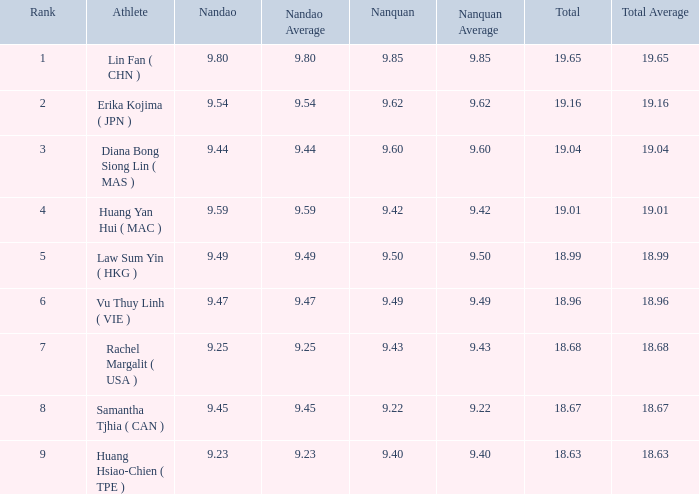Parse the full table. {'header': ['Rank', 'Athlete', 'Nandao', 'Nandao Average', 'Nanquan', 'Nanquan Average', 'Total', 'Total Average'], 'rows': [['1', 'Lin Fan ( CHN )', '9.80', '9.80', '9.85', '9.85', '19.65', '19.65'], ['2', 'Erika Kojima ( JPN )', '9.54', '9.54', '9.62', '9.62', '19.16', '19.16'], ['3', 'Diana Bong Siong Lin ( MAS )', '9.44', '9.44', '9.60', '9.60', '19.04', '19.04'], ['4', 'Huang Yan Hui ( MAC )', '9.59', '9.59', '9.42', '9.42', '19.01', '19.01'], ['5', 'Law Sum Yin ( HKG )', '9.49', '9.49', '9.50', '9.50', '18.99', '18.99'], ['6', 'Vu Thuy Linh ( VIE )', '9.47', '9.47', '9.49', '9.49', '18.96', '18.96'], ['7', 'Rachel Margalit ( USA )', '9.25', '9.25', '9.43', '9.43', '18.68', '18.68'], ['8', 'Samantha Tjhia ( CAN )', '9.45', '9.45', '9.22', '9.22', '18.67', '18.67'], ['9', 'Huang Hsiao-Chien ( TPE )', '9.23', '9.23', '9.40', '9.40', '18.63', '18.63']]} Which Nanquan has a Nandao larger than 9.49, and a Rank of 4? 9.42. 